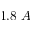<formula> <loc_0><loc_0><loc_500><loc_500>1 . 8 \, A</formula> 